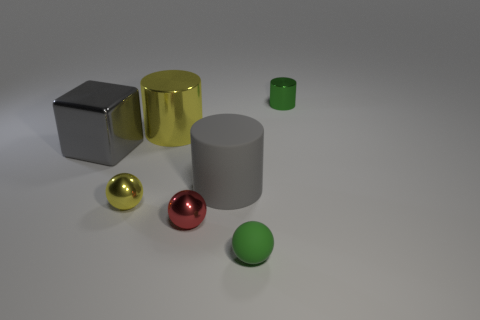Add 3 shiny blocks. How many objects exist? 10 Subtract all cylinders. How many objects are left? 4 Add 7 small yellow things. How many small yellow things are left? 8 Add 5 red metallic objects. How many red metallic objects exist? 6 Subtract 0 blue cylinders. How many objects are left? 7 Subtract all green matte spheres. Subtract all gray rubber cylinders. How many objects are left? 5 